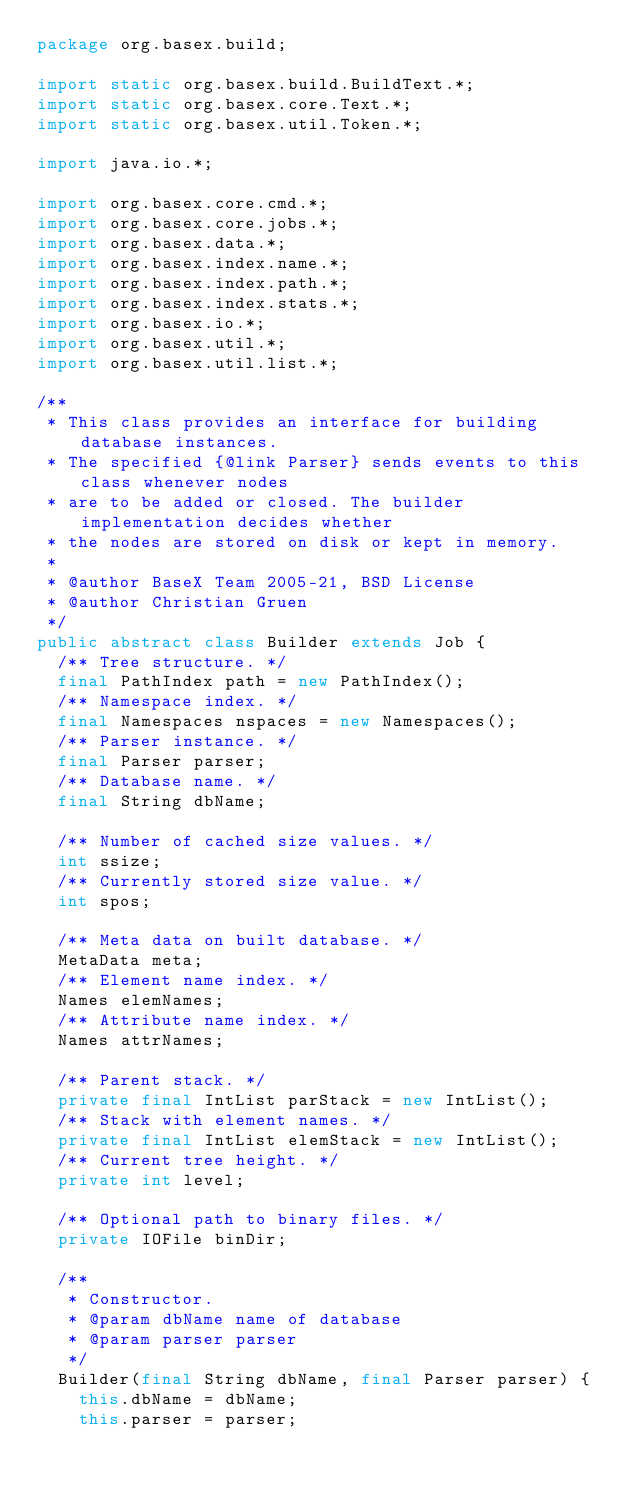<code> <loc_0><loc_0><loc_500><loc_500><_Java_>package org.basex.build;

import static org.basex.build.BuildText.*;
import static org.basex.core.Text.*;
import static org.basex.util.Token.*;

import java.io.*;

import org.basex.core.cmd.*;
import org.basex.core.jobs.*;
import org.basex.data.*;
import org.basex.index.name.*;
import org.basex.index.path.*;
import org.basex.index.stats.*;
import org.basex.io.*;
import org.basex.util.*;
import org.basex.util.list.*;

/**
 * This class provides an interface for building database instances.
 * The specified {@link Parser} sends events to this class whenever nodes
 * are to be added or closed. The builder implementation decides whether
 * the nodes are stored on disk or kept in memory.
 *
 * @author BaseX Team 2005-21, BSD License
 * @author Christian Gruen
 */
public abstract class Builder extends Job {
  /** Tree structure. */
  final PathIndex path = new PathIndex();
  /** Namespace index. */
  final Namespaces nspaces = new Namespaces();
  /** Parser instance. */
  final Parser parser;
  /** Database name. */
  final String dbName;

  /** Number of cached size values. */
  int ssize;
  /** Currently stored size value. */
  int spos;

  /** Meta data on built database. */
  MetaData meta;
  /** Element name index. */
  Names elemNames;
  /** Attribute name index. */
  Names attrNames;

  /** Parent stack. */
  private final IntList parStack = new IntList();
  /** Stack with element names. */
  private final IntList elemStack = new IntList();
  /** Current tree height. */
  private int level;

  /** Optional path to binary files. */
  private IOFile binDir;

  /**
   * Constructor.
   * @param dbName name of database
   * @param parser parser
   */
  Builder(final String dbName, final Parser parser) {
    this.dbName = dbName;
    this.parser = parser;</code> 